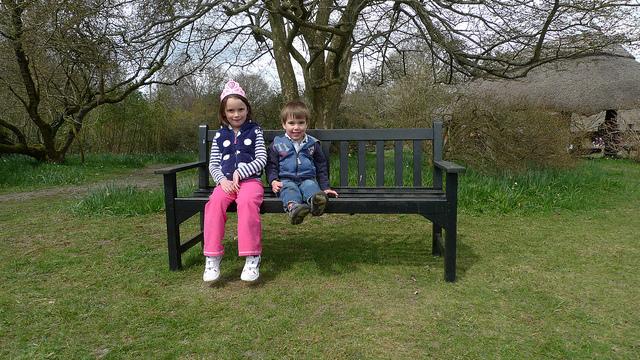Where are the children sitting?
Write a very short answer. Bench. Is the little girl wearing a hat?
Quick response, please. Yes. Are these color choices gender-traditional?
Short answer required. Yes. 